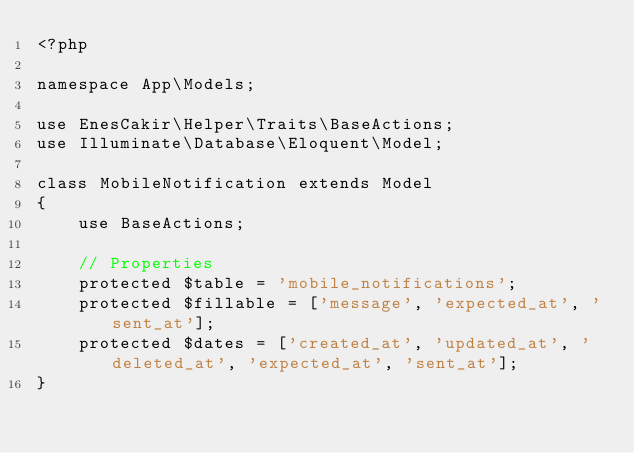<code> <loc_0><loc_0><loc_500><loc_500><_PHP_><?php

namespace App\Models;

use EnesCakir\Helper\Traits\BaseActions;
use Illuminate\Database\Eloquent\Model;

class MobileNotification extends Model
{
    use BaseActions;

    // Properties
    protected $table = 'mobile_notifications';
    protected $fillable = ['message', 'expected_at', 'sent_at'];
    protected $dates = ['created_at', 'updated_at', 'deleted_at', 'expected_at', 'sent_at'];
}
</code> 